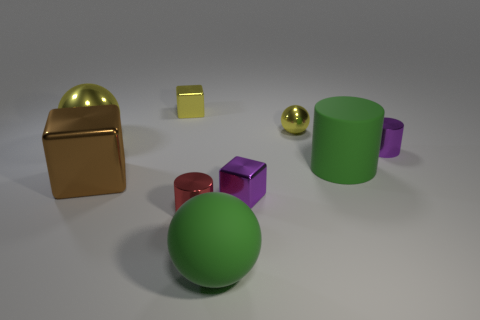Are there any yellow spheres on the right side of the small purple cylinder?
Make the answer very short. No. What is the color of the matte thing in front of the small block that is in front of the purple object that is behind the big green cylinder?
Your response must be concise. Green. What number of large objects are in front of the brown block and behind the purple metallic cube?
Make the answer very short. 0. What number of spheres are either large shiny things or small yellow objects?
Your answer should be compact. 2. Are any tiny gray metallic spheres visible?
Offer a very short reply. No. How many other things are there of the same material as the brown block?
Your response must be concise. 6. What is the material of the green cylinder that is the same size as the brown metal block?
Ensure brevity in your answer.  Rubber. There is a big brown metal thing behind the red thing; does it have the same shape as the tiny red thing?
Provide a short and direct response. No. Is the big cylinder the same color as the tiny sphere?
Your answer should be very brief. No. What number of objects are either large green matte objects behind the red cylinder or large brown spheres?
Your response must be concise. 1. 